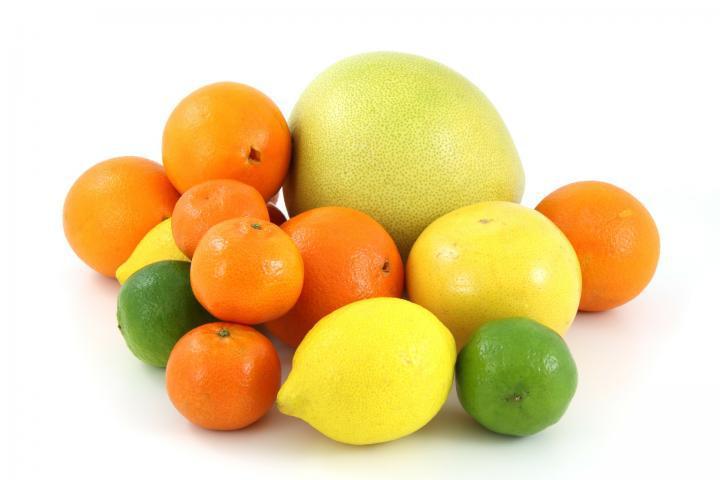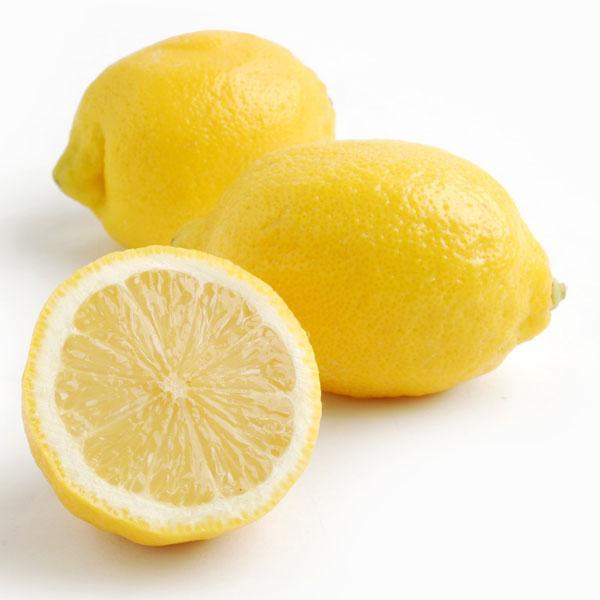The first image is the image on the left, the second image is the image on the right. For the images displayed, is the sentence "In at least one image there are at least four different types of citrus fruit." factually correct? Answer yes or no. Yes. The first image is the image on the left, the second image is the image on the right. Assess this claim about the two images: "The right image contains three lemons, one of which has been cut in half.". Correct or not? Answer yes or no. Yes. 